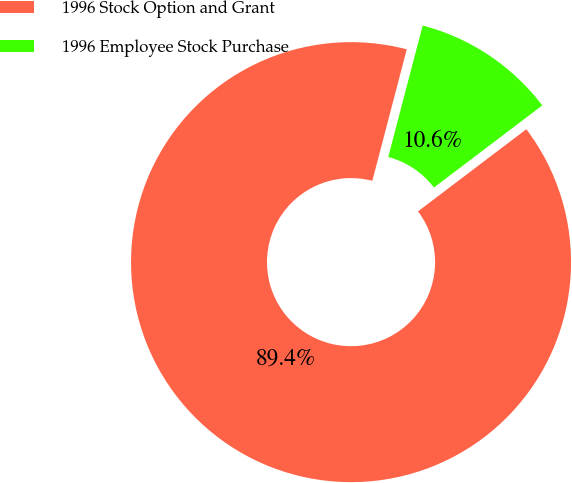Convert chart to OTSL. <chart><loc_0><loc_0><loc_500><loc_500><pie_chart><fcel>1996 Stock Option and Grant<fcel>1996 Employee Stock Purchase<nl><fcel>89.4%<fcel>10.6%<nl></chart> 